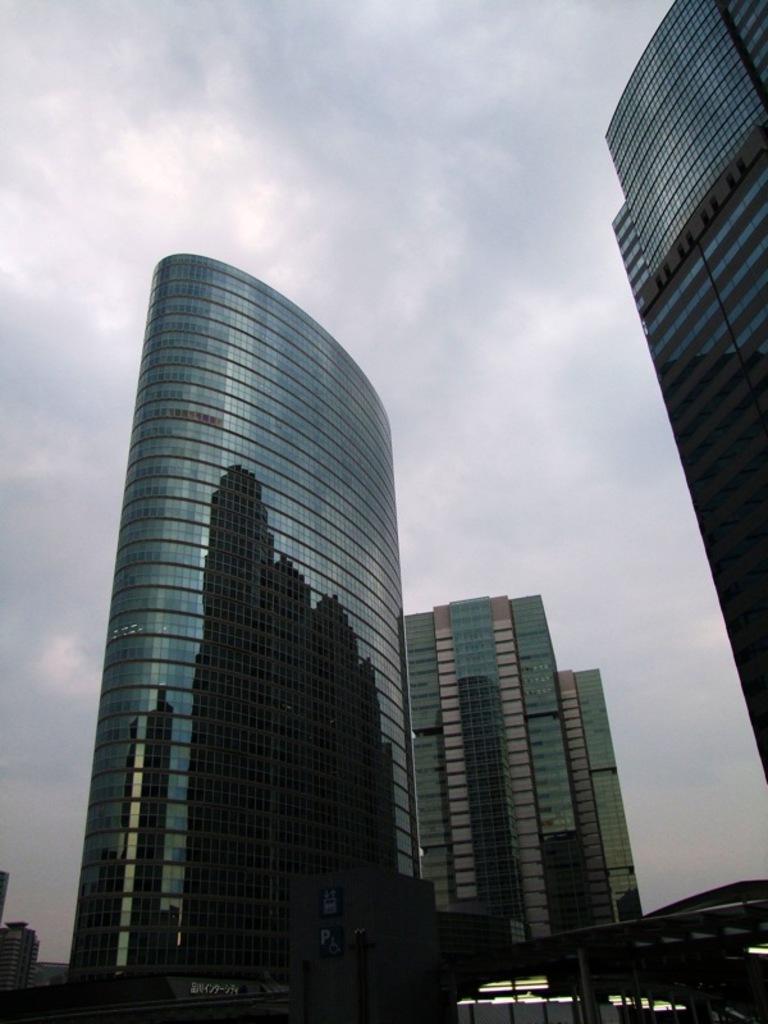Describe this image in one or two sentences. In this picture there are buildings and there is text on the wall and there are boards on the wall and there are poles and there are lights. At the top there is sky and there are clouds. 